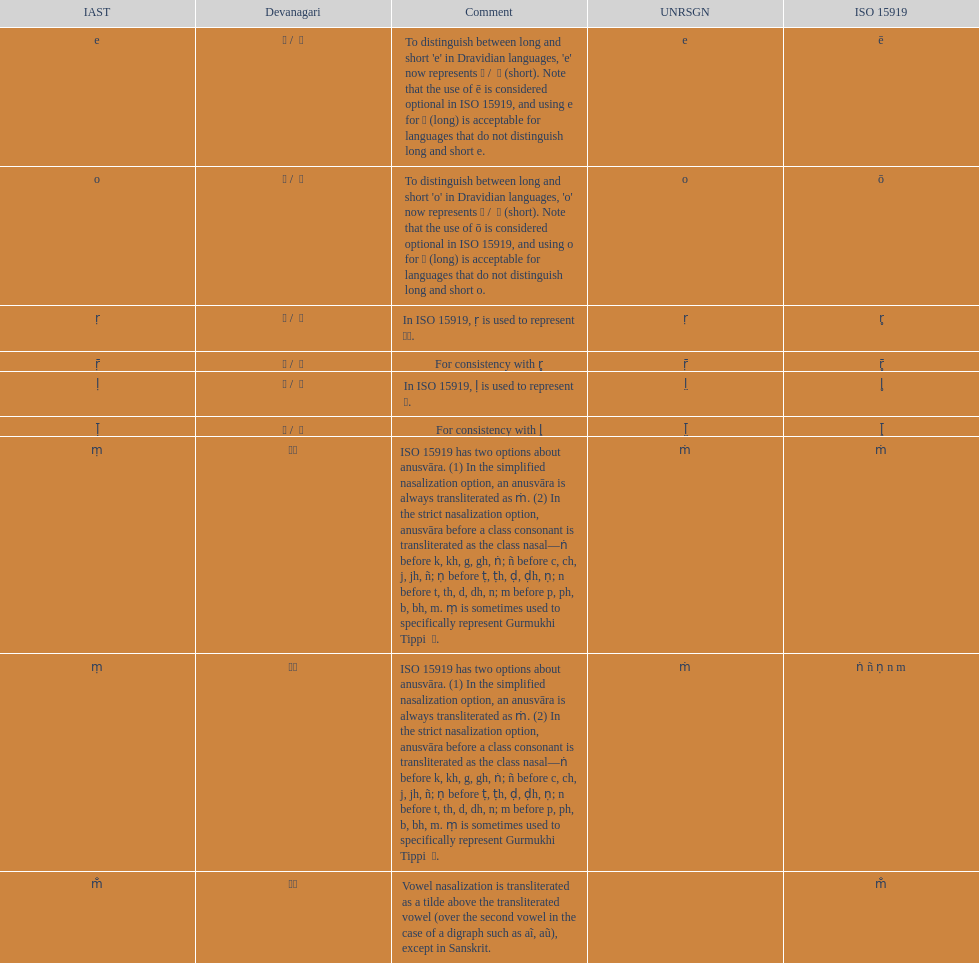What is listed previous to in iso 15919, &#7735; is used to represent &#2355;. under comments? For consistency with r̥. 